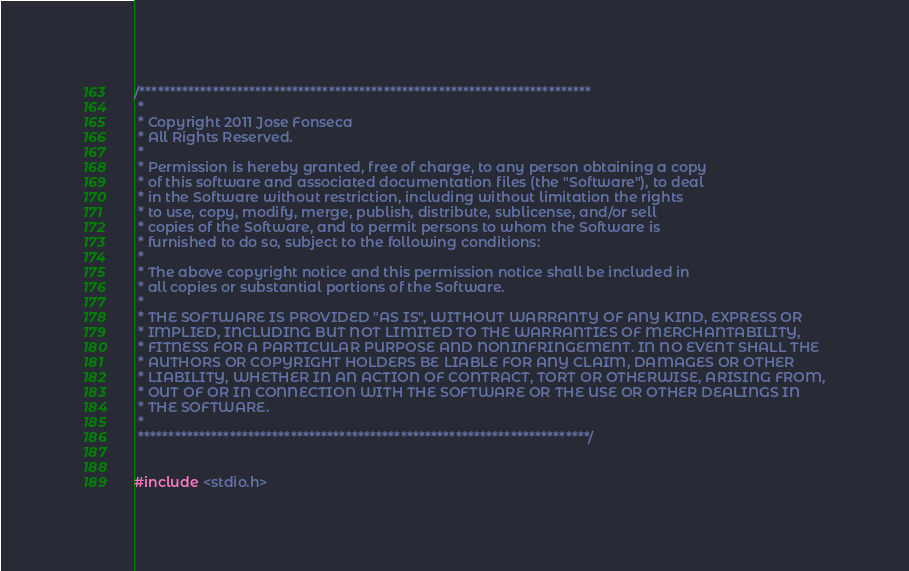Convert code to text. <code><loc_0><loc_0><loc_500><loc_500><_C++_>/**************************************************************************
 *
 * Copyright 2011 Jose Fonseca
 * All Rights Reserved.
 *
 * Permission is hereby granted, free of charge, to any person obtaining a copy
 * of this software and associated documentation files (the "Software"), to deal
 * in the Software without restriction, including without limitation the rights
 * to use, copy, modify, merge, publish, distribute, sublicense, and/or sell
 * copies of the Software, and to permit persons to whom the Software is
 * furnished to do so, subject to the following conditions:
 *
 * The above copyright notice and this permission notice shall be included in
 * all copies or substantial portions of the Software.
 *
 * THE SOFTWARE IS PROVIDED "AS IS", WITHOUT WARRANTY OF ANY KIND, EXPRESS OR
 * IMPLIED, INCLUDING BUT NOT LIMITED TO THE WARRANTIES OF MERCHANTABILITY,
 * FITNESS FOR A PARTICULAR PURPOSE AND NONINFRINGEMENT. IN NO EVENT SHALL THE
 * AUTHORS OR COPYRIGHT HOLDERS BE LIABLE FOR ANY CLAIM, DAMAGES OR OTHER
 * LIABILITY, WHETHER IN AN ACTION OF CONTRACT, TORT OR OTHERWISE, ARISING FROM,
 * OUT OF OR IN CONNECTION WITH THE SOFTWARE OR THE USE OR OTHER DEALINGS IN
 * THE SOFTWARE.
 *
 **************************************************************************/


#include <stdio.h>
</code> 